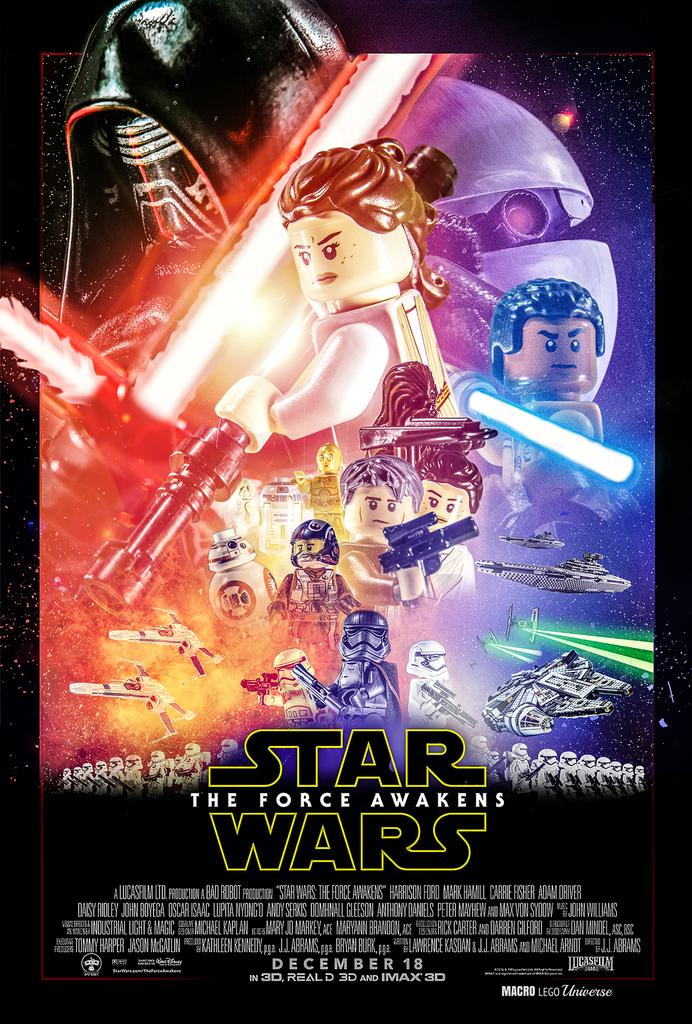<image>
Summarize the visual content of the image. Poster for Lego Star Wars that comes out on December 18th. 